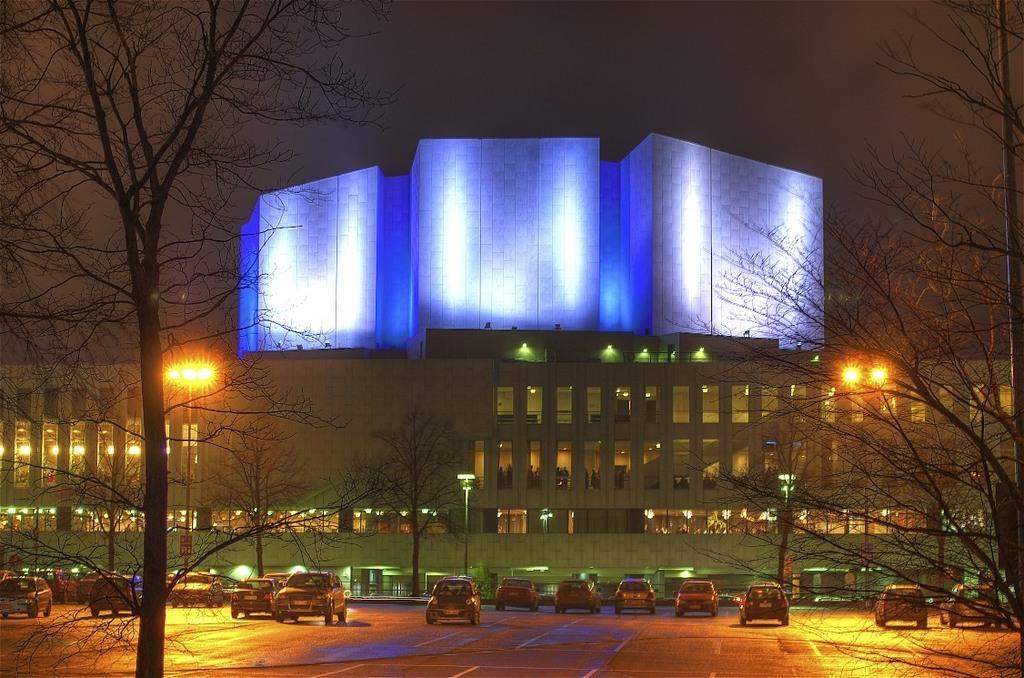Can you describe this image briefly? In this image there are trees in the left and right corner. There is a road at the bottom. There are vehicles in the foreground. There are buildings, poles with lights and trees in the background. And the sky is very dark at the top. 